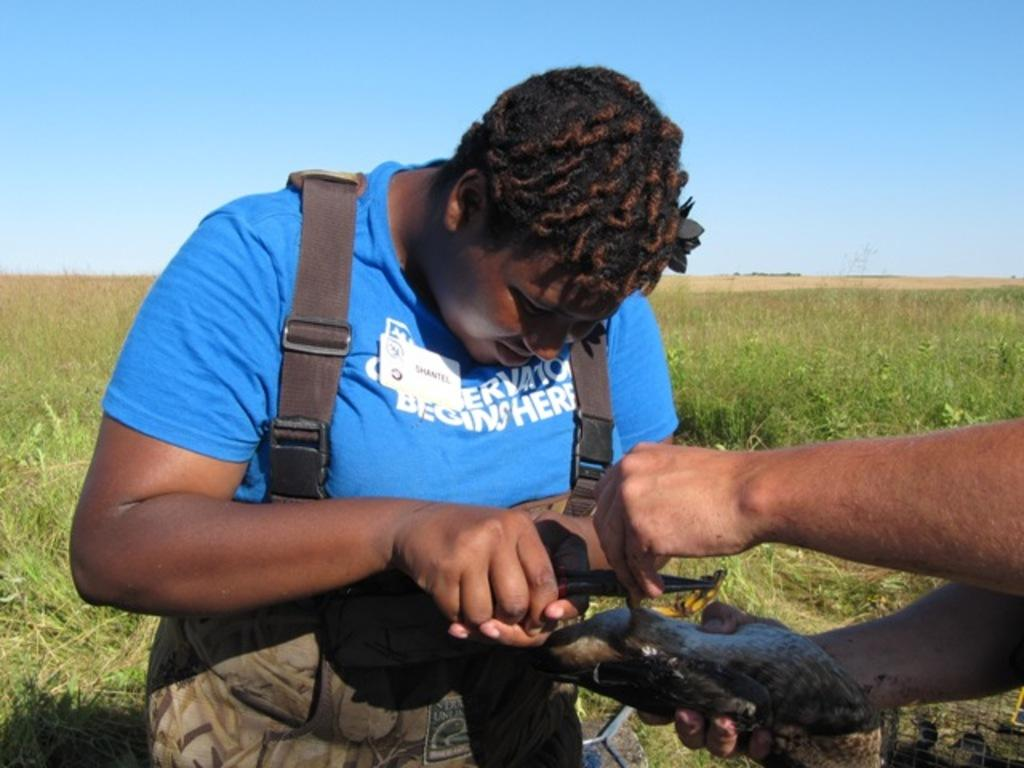How many people are present in the image? There are two persons in the image. What are the people doing in the image? One person is holding an object, and the other person is cutting an object. What can be seen in the background of the image? There is grass visible in the background of the image. Can you tell me how many wings are visible in the image? There are no wings present in the image. What type of scene is being depicted in the image? The image does not depict a specific scene; it simply shows two people engaged in different activities. 